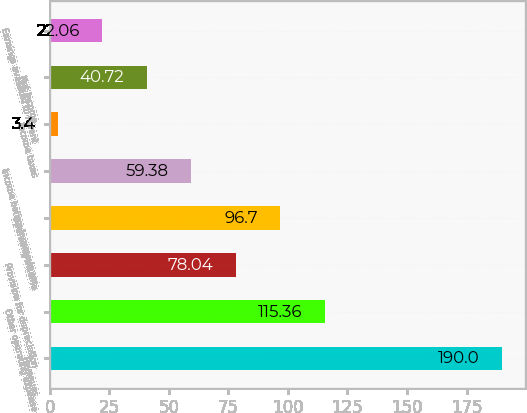Convert chart. <chart><loc_0><loc_0><loc_500><loc_500><bar_chart><fcel>Revenues<fcel>Other operating expense<fcel>Provision for depreciation<fcel>Operating Income<fcel>Income before income taxes<fcel>Income taxes<fcel>Net Income<fcel>Earnings available to Parent<nl><fcel>190<fcel>115.36<fcel>78.04<fcel>96.7<fcel>59.38<fcel>3.4<fcel>40.72<fcel>22.06<nl></chart> 